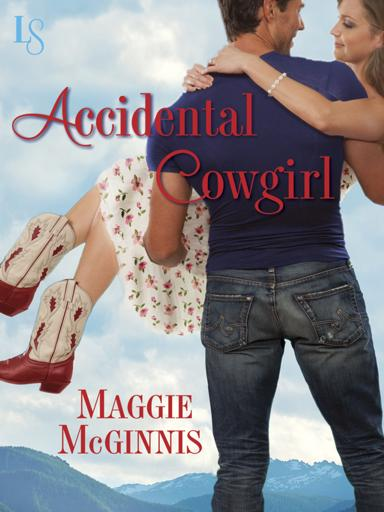Can you tell me the title and author of the book mentioned in the image? The book shown in the image is titled "Accidental Cowgirl," authored by Maggie McGinnis. It's prominently displayed as the woman, dressed in a floral dress and cowboy boots, is being lifted by a man. 